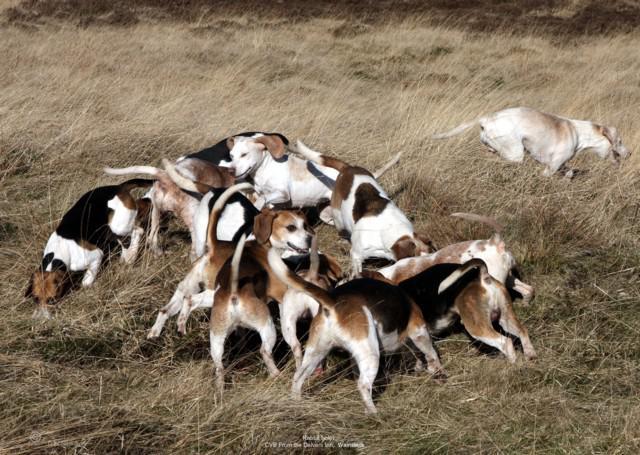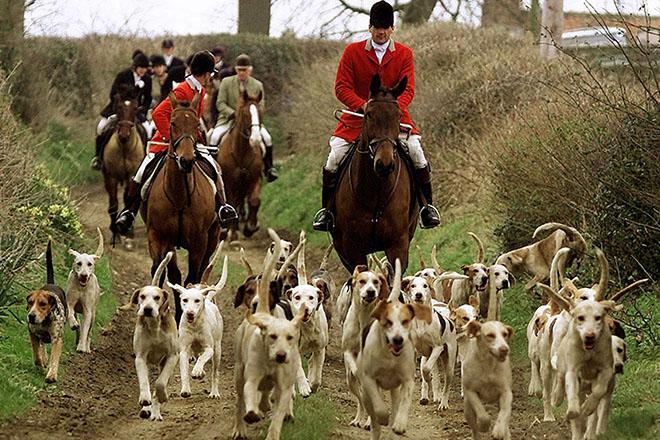The first image is the image on the left, the second image is the image on the right. Analyze the images presented: Is the assertion "One image contains exactly two animals, at least one of them a beagle." valid? Answer yes or no. No. The first image is the image on the left, the second image is the image on the right. Examine the images to the left and right. Is the description "There are people near some of the dogs." accurate? Answer yes or no. Yes. 